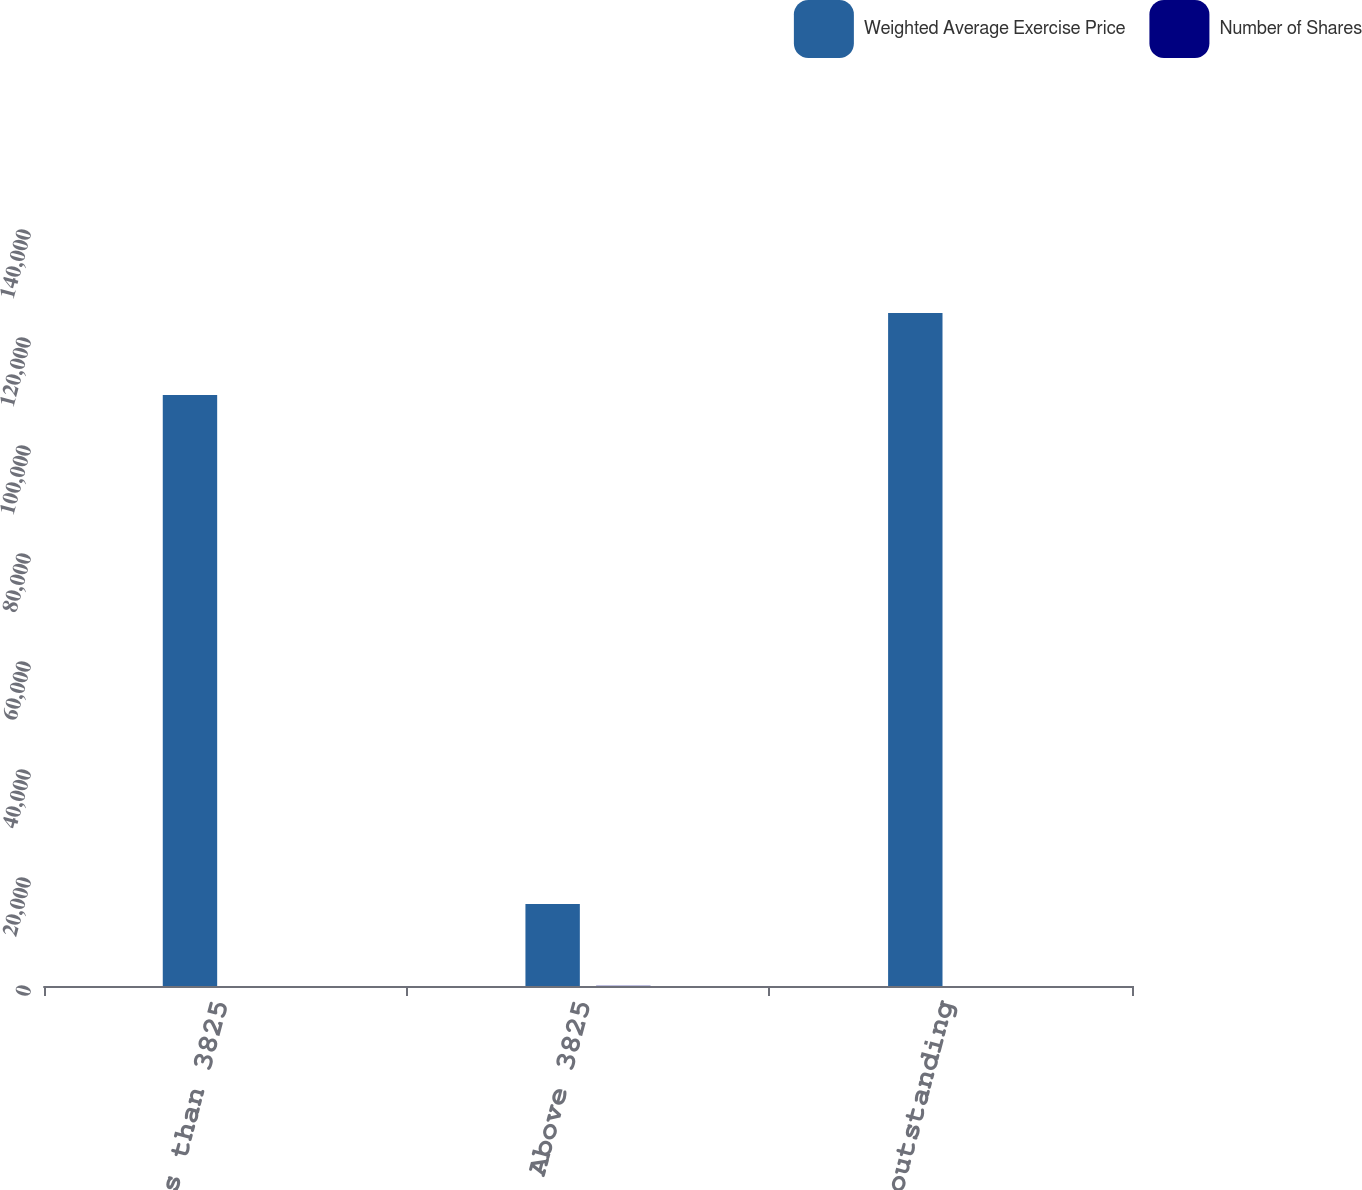Convert chart to OTSL. <chart><loc_0><loc_0><loc_500><loc_500><stacked_bar_chart><ecel><fcel>Less than 3825<fcel>Above 3825<fcel>Total outstanding<nl><fcel>Weighted Average Exercise Price<fcel>109448<fcel>15202<fcel>124650<nl><fcel>Number of Shares<fcel>13.36<fcel>46.53<fcel>17.41<nl></chart> 